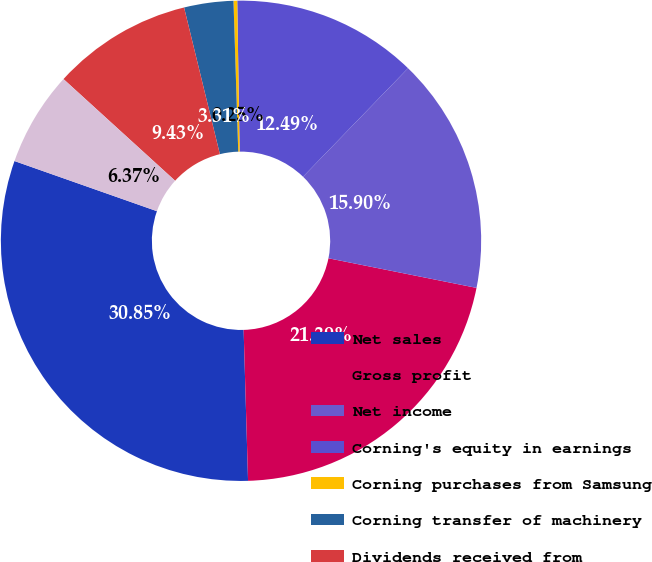Convert chart. <chart><loc_0><loc_0><loc_500><loc_500><pie_chart><fcel>Net sales<fcel>Gross profit<fcel>Net income<fcel>Corning's equity in earnings<fcel>Corning purchases from Samsung<fcel>Corning transfer of machinery<fcel>Dividends received from<fcel>Royalty income from Samsung<nl><fcel>30.85%<fcel>21.39%<fcel>15.9%<fcel>12.49%<fcel>0.25%<fcel>3.31%<fcel>9.43%<fcel>6.37%<nl></chart> 